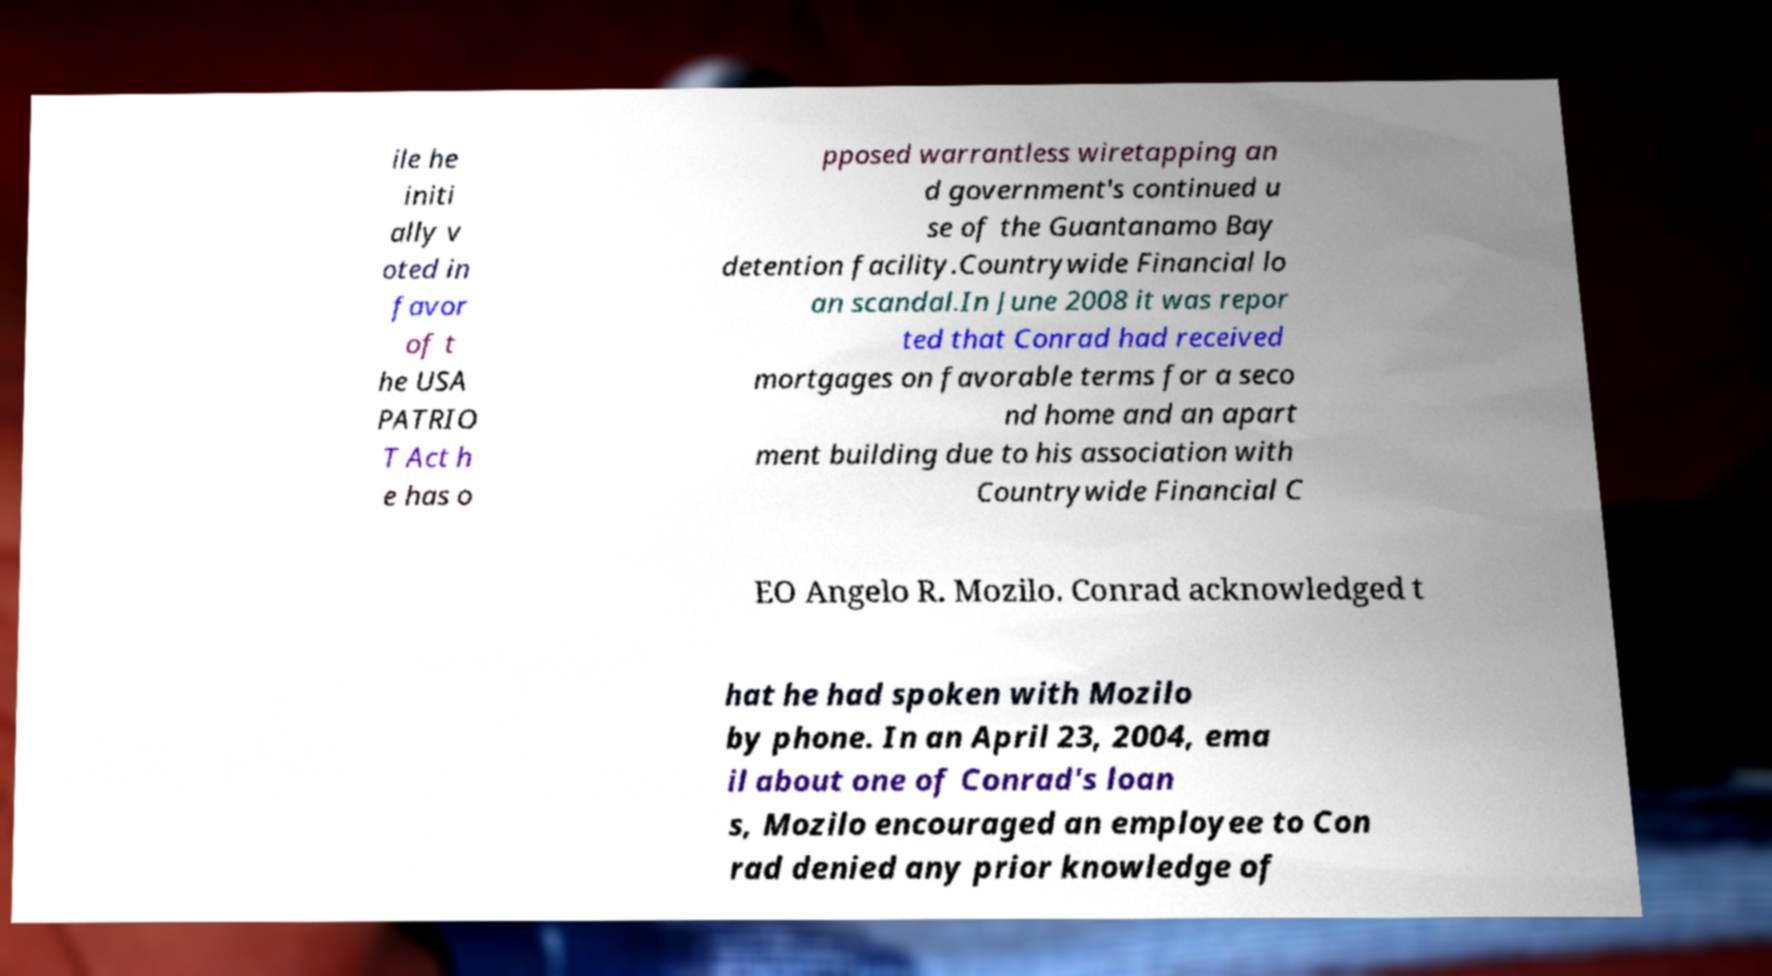For documentation purposes, I need the text within this image transcribed. Could you provide that? ile he initi ally v oted in favor of t he USA PATRIO T Act h e has o pposed warrantless wiretapping an d government's continued u se of the Guantanamo Bay detention facility.Countrywide Financial lo an scandal.In June 2008 it was repor ted that Conrad had received mortgages on favorable terms for a seco nd home and an apart ment building due to his association with Countrywide Financial C EO Angelo R. Mozilo. Conrad acknowledged t hat he had spoken with Mozilo by phone. In an April 23, 2004, ema il about one of Conrad's loan s, Mozilo encouraged an employee to Con rad denied any prior knowledge of 